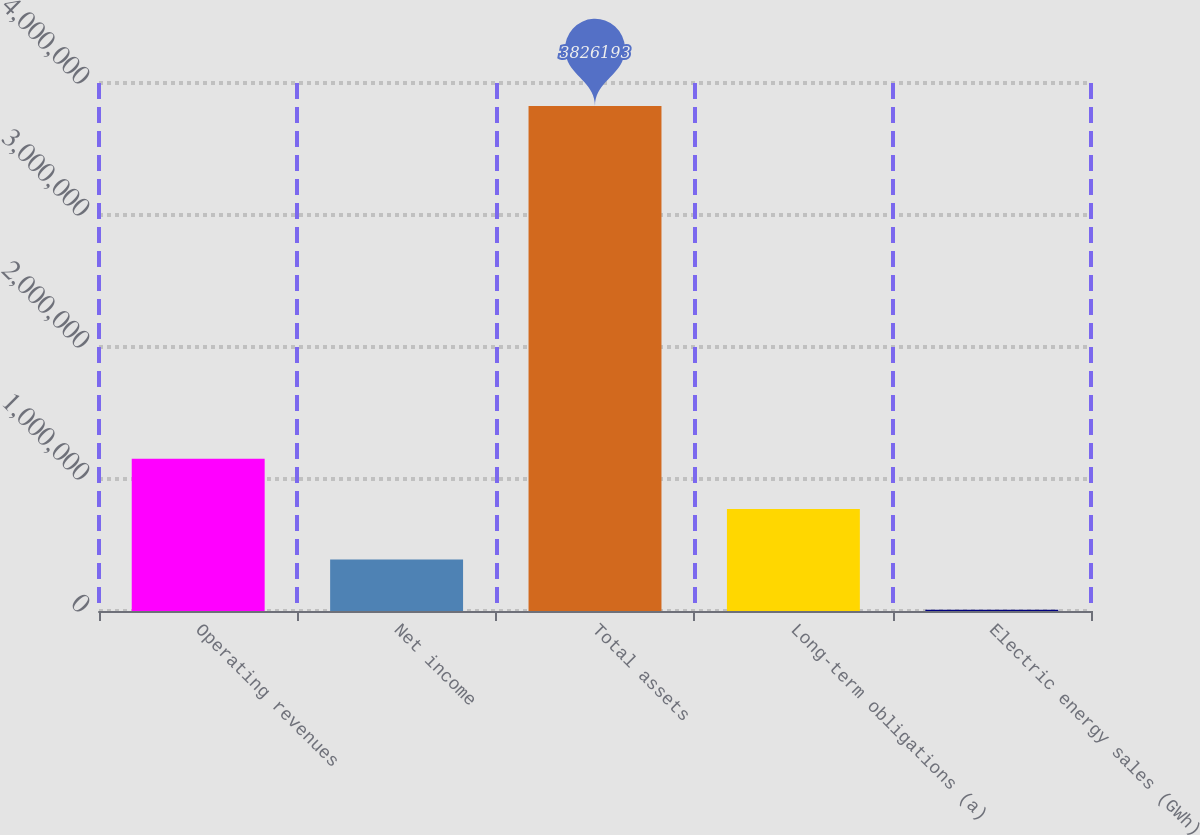Convert chart to OTSL. <chart><loc_0><loc_0><loc_500><loc_500><bar_chart><fcel>Operating revenues<fcel>Net income<fcel>Total assets<fcel>Long-term obligations (a)<fcel>Electric energy sales (GWh)<nl><fcel>1.15431e+06<fcel>390916<fcel>3.82619e+06<fcel>772614<fcel>9219<nl></chart> 